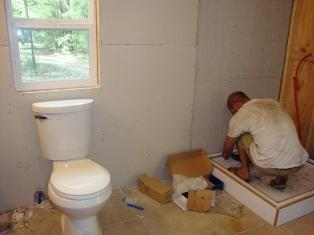Question: what room is this?
Choices:
A. Bathroom.
B. Kitchen.
C. Living room.
D. Office.
Answer with the letter. Answer: A 